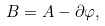<formula> <loc_0><loc_0><loc_500><loc_500>B = A - \partial \varphi ,</formula> 